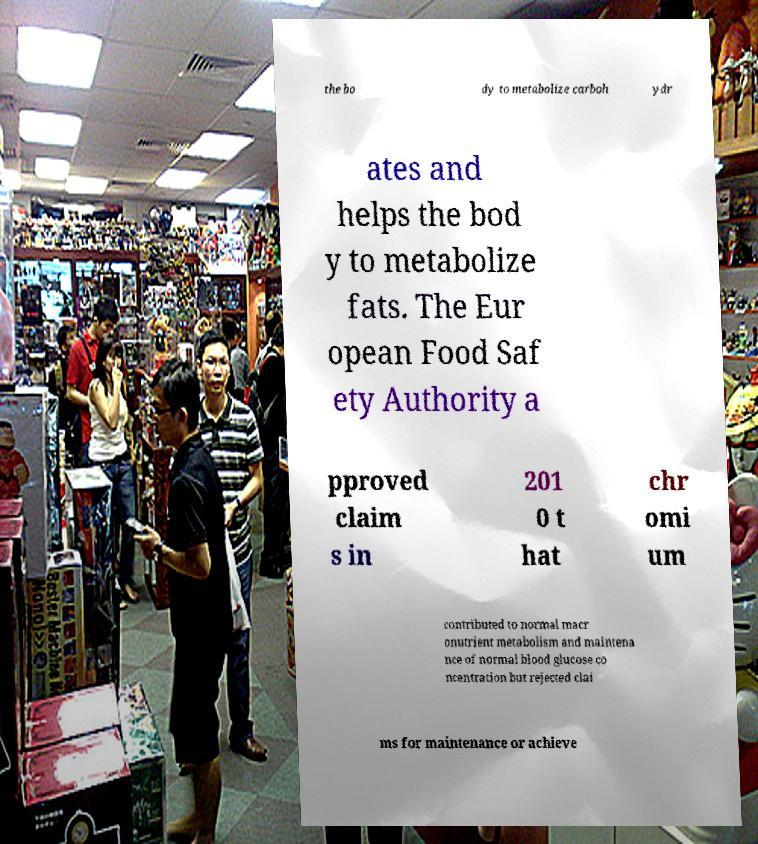Can you accurately transcribe the text from the provided image for me? the bo dy to metabolize carboh ydr ates and helps the bod y to metabolize fats. The Eur opean Food Saf ety Authority a pproved claim s in 201 0 t hat chr omi um contributed to normal macr onutrient metabolism and maintena nce of normal blood glucose co ncentration but rejected clai ms for maintenance or achieve 